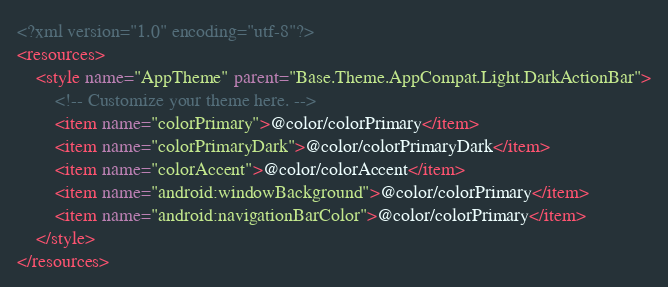<code> <loc_0><loc_0><loc_500><loc_500><_XML_><?xml version="1.0" encoding="utf-8"?>
<resources>
    <style name="AppTheme" parent="Base.Theme.AppCompat.Light.DarkActionBar">
        <!-- Customize your theme here. -->
        <item name="colorPrimary">@color/colorPrimary</item>
        <item name="colorPrimaryDark">@color/colorPrimaryDark</item>
        <item name="colorAccent">@color/colorAccent</item>
        <item name="android:windowBackground">@color/colorPrimary</item>
        <item name="android:navigationBarColor">@color/colorPrimary</item>
    </style>
</resources></code> 